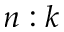Convert formula to latex. <formula><loc_0><loc_0><loc_500><loc_500>n \colon k</formula> 